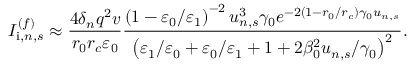Convert formula to latex. <formula><loc_0><loc_0><loc_500><loc_500>I _ { i , n , s } ^ { ( f ) } \approx \frac { 4 \delta _ { n } q ^ { 2 } v } { r _ { 0 } r _ { c } \varepsilon _ { 0 } } \frac { \left ( 1 - \varepsilon _ { 0 } / \varepsilon _ { 1 } \right ) ^ { - 2 } u _ { n , s } ^ { 3 } \gamma _ { 0 } e ^ { - 2 \left ( 1 - r _ { 0 } / r _ { c } \right ) \gamma _ { 0 } u _ { n , s } } } { \left ( \varepsilon _ { 1 } / \varepsilon _ { 0 } + \varepsilon _ { 0 } / \varepsilon _ { 1 } + 1 + 2 \beta _ { 0 } ^ { 2 } u _ { n , s } / \gamma _ { 0 } \right ) ^ { 2 } } .</formula> 